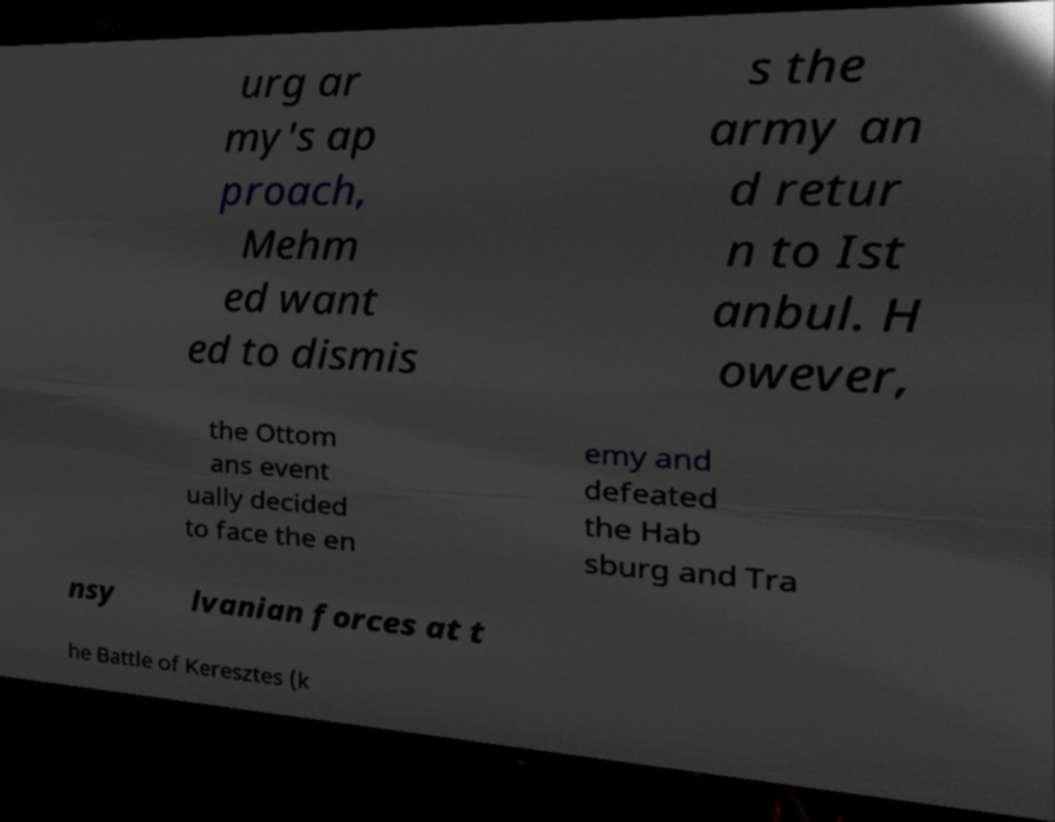What messages or text are displayed in this image? I need them in a readable, typed format. urg ar my's ap proach, Mehm ed want ed to dismis s the army an d retur n to Ist anbul. H owever, the Ottom ans event ually decided to face the en emy and defeated the Hab sburg and Tra nsy lvanian forces at t he Battle of Keresztes (k 